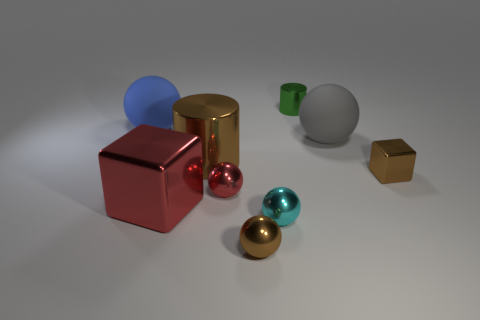There is a object that is the same color as the large block; what shape is it?
Your answer should be compact. Sphere. What is the material of the big object that is the same color as the tiny cube?
Your answer should be compact. Metal. Are there any tiny brown blocks made of the same material as the green thing?
Give a very brief answer. Yes. There is a rubber thing that is right of the cylinder on the right side of the tiny brown shiny sphere; is there a large brown cylinder that is behind it?
Your answer should be very brief. No. What number of other objects are there of the same shape as the gray rubber object?
Make the answer very short. 4. What is the color of the large rubber ball that is right of the matte object on the left side of the brown metallic thing in front of the small metallic cube?
Ensure brevity in your answer.  Gray. What number of large cyan matte blocks are there?
Your response must be concise. 0. What number of tiny objects are either green metallic cylinders or rubber objects?
Provide a succinct answer. 1. There is a red object that is the same size as the brown shiny block; what shape is it?
Provide a short and direct response. Sphere. Is there anything else that is the same size as the red sphere?
Keep it short and to the point. Yes. 